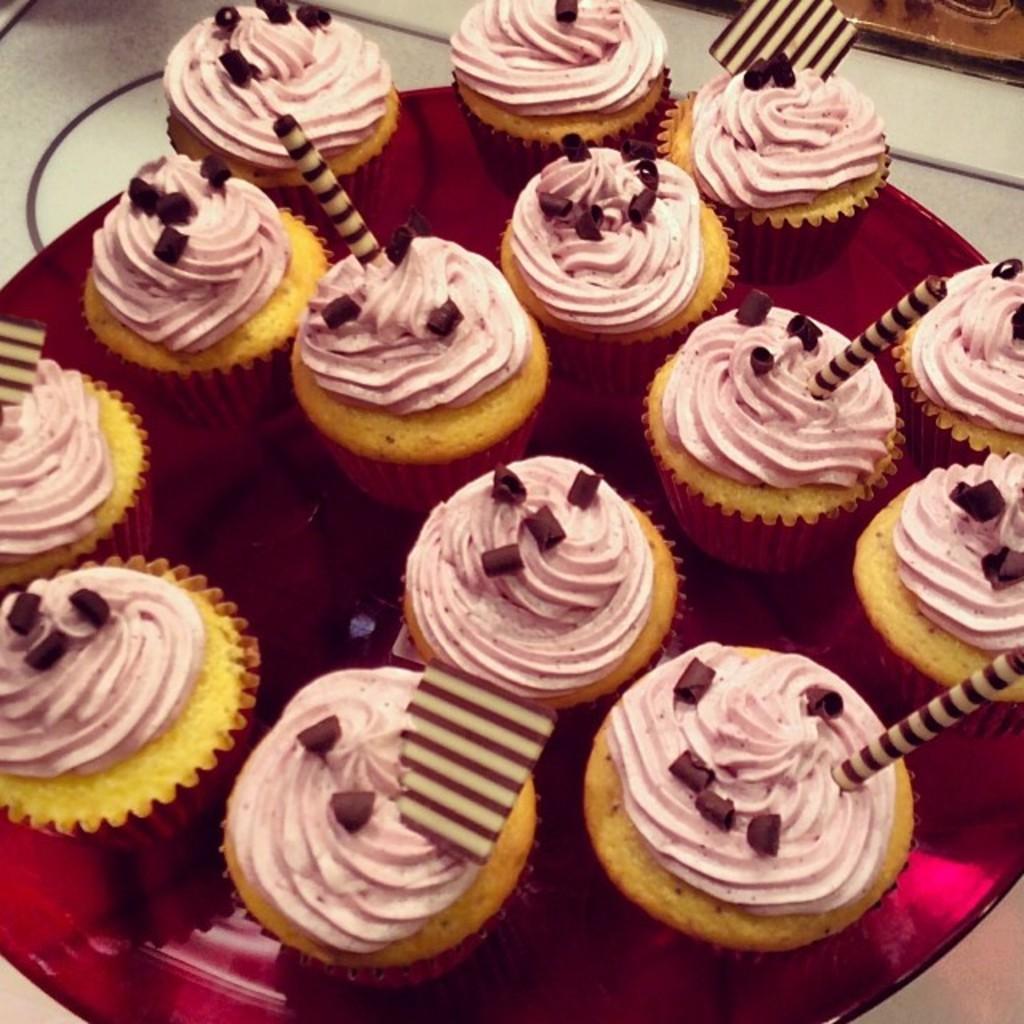Can you describe this image briefly? In this picture we can see a plate on the surface with cupcakes in it. 